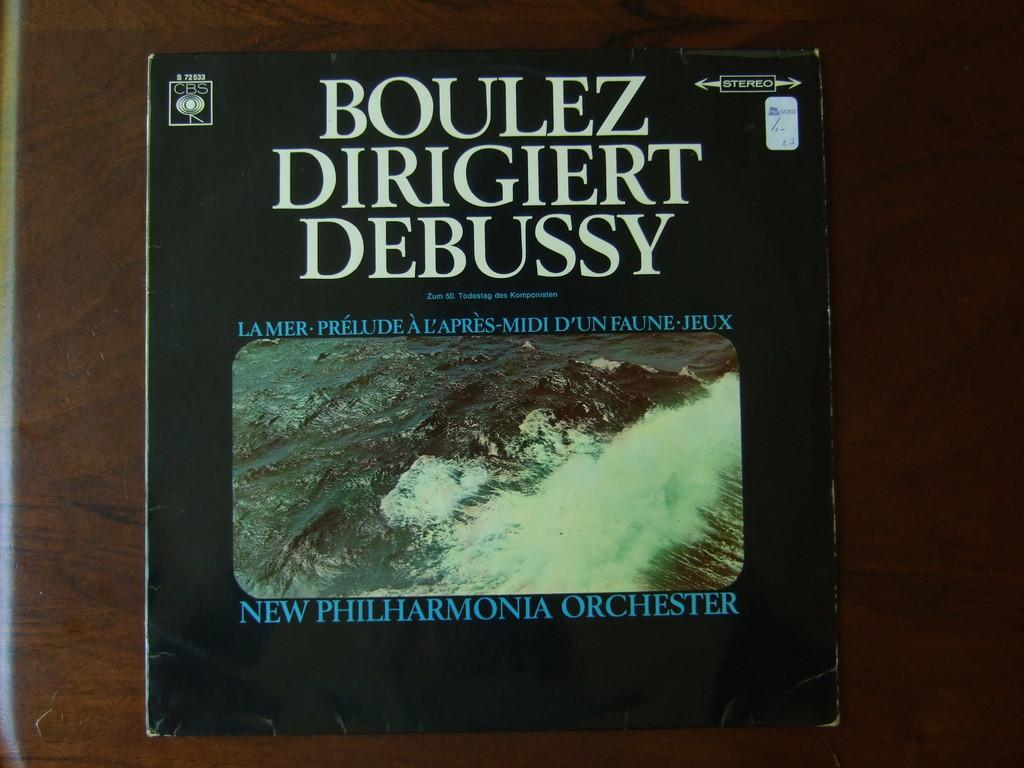<image>
Present a compact description of the photo's key features. A book called the Boulez dirigiert debussy from the new philharmonia orchester 